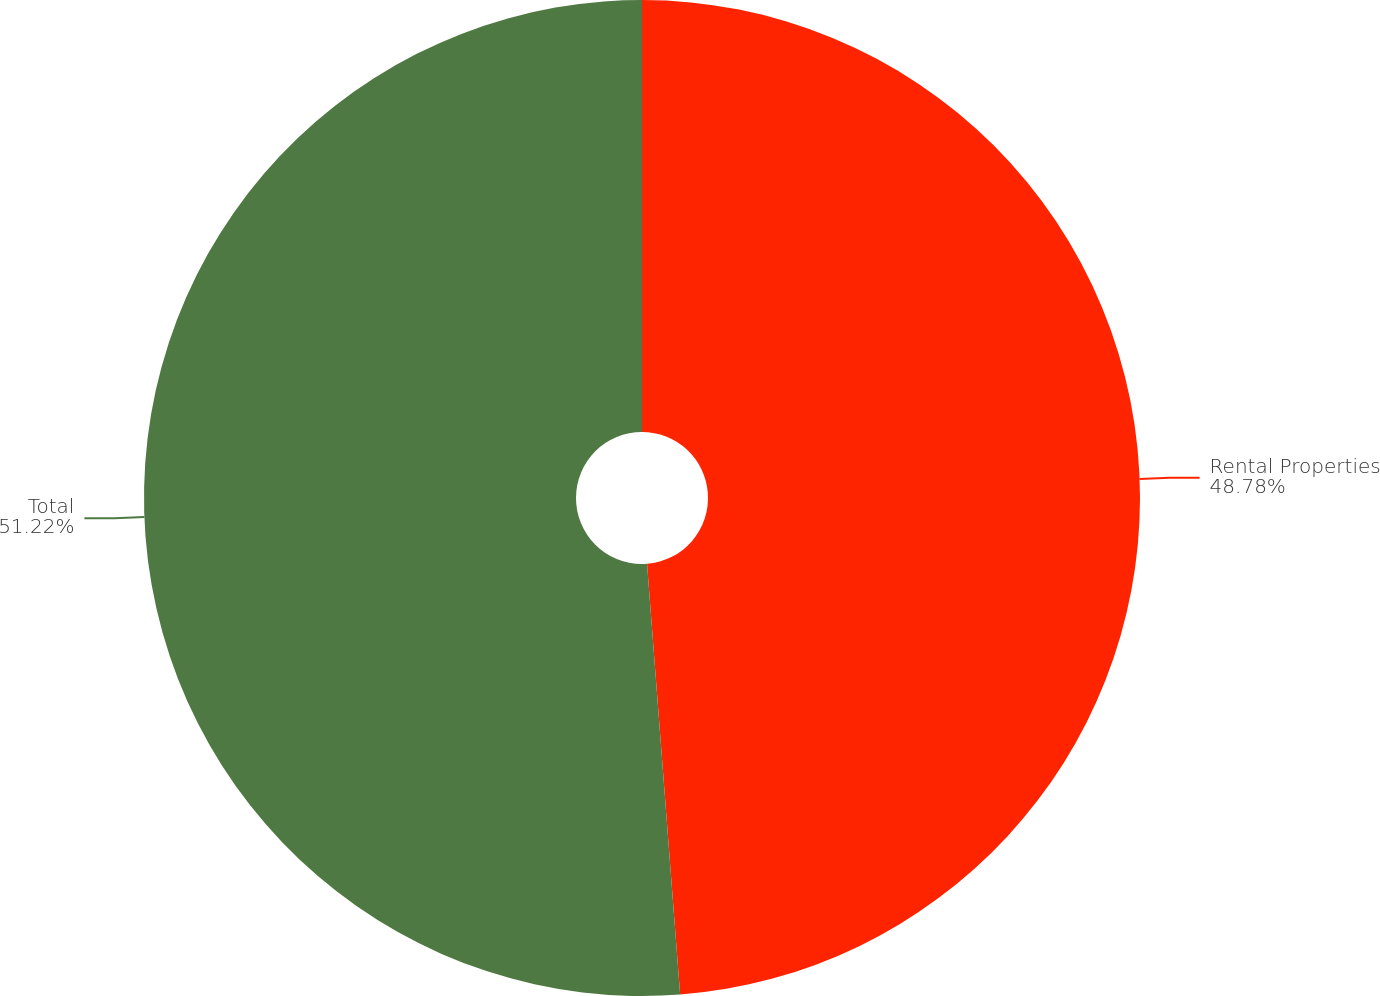Convert chart to OTSL. <chart><loc_0><loc_0><loc_500><loc_500><pie_chart><fcel>Rental Properties<fcel>Total<nl><fcel>48.78%<fcel>51.22%<nl></chart> 